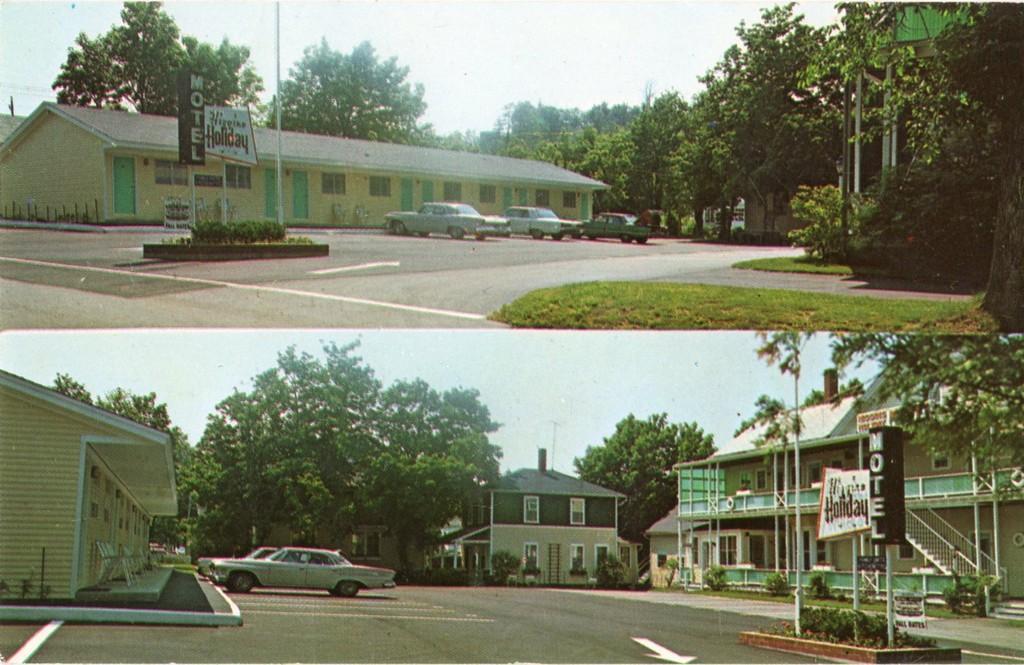In one or two sentences, can you explain what this image depicts? This looks like a collage picture. These are the houses with windows. I can see the stairs with the staircase holder. These look like chairs. These are the trees. I can see cars, which are parked. These look like boards, which are attached to the poles. Here is the grass. 